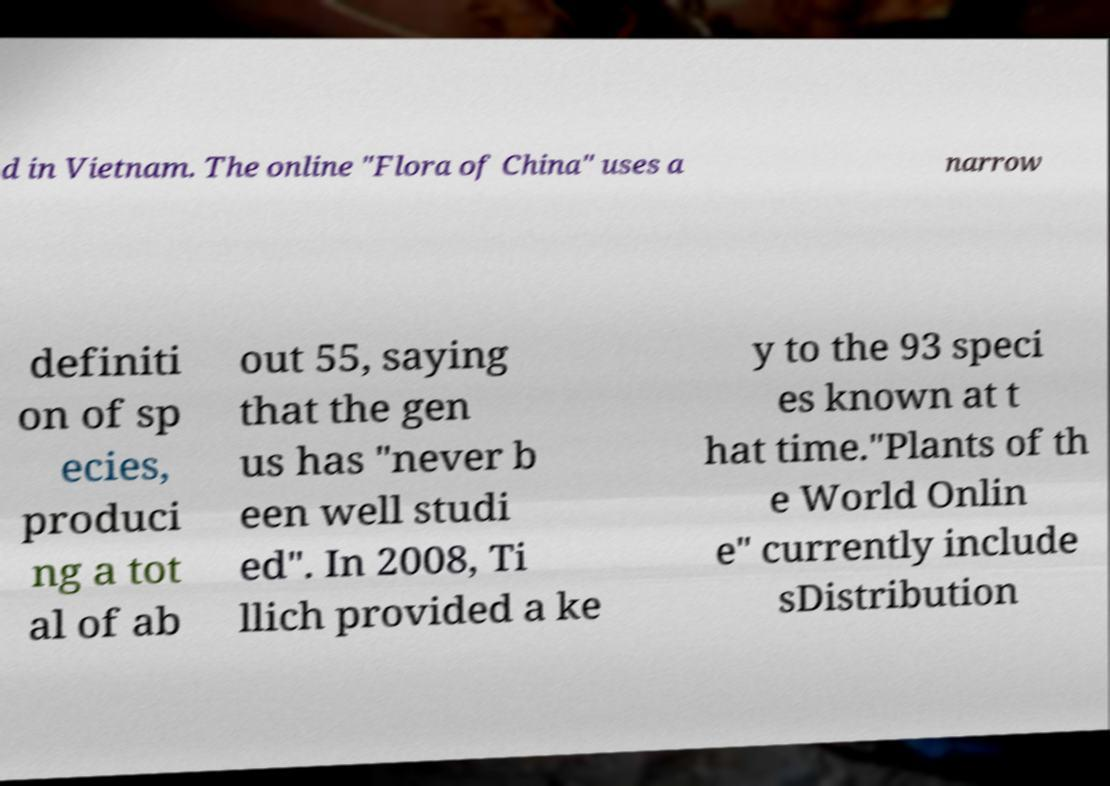Can you accurately transcribe the text from the provided image for me? d in Vietnam. The online "Flora of China" uses a narrow definiti on of sp ecies, produci ng a tot al of ab out 55, saying that the gen us has "never b een well studi ed". In 2008, Ti llich provided a ke y to the 93 speci es known at t hat time."Plants of th e World Onlin e" currently include sDistribution 